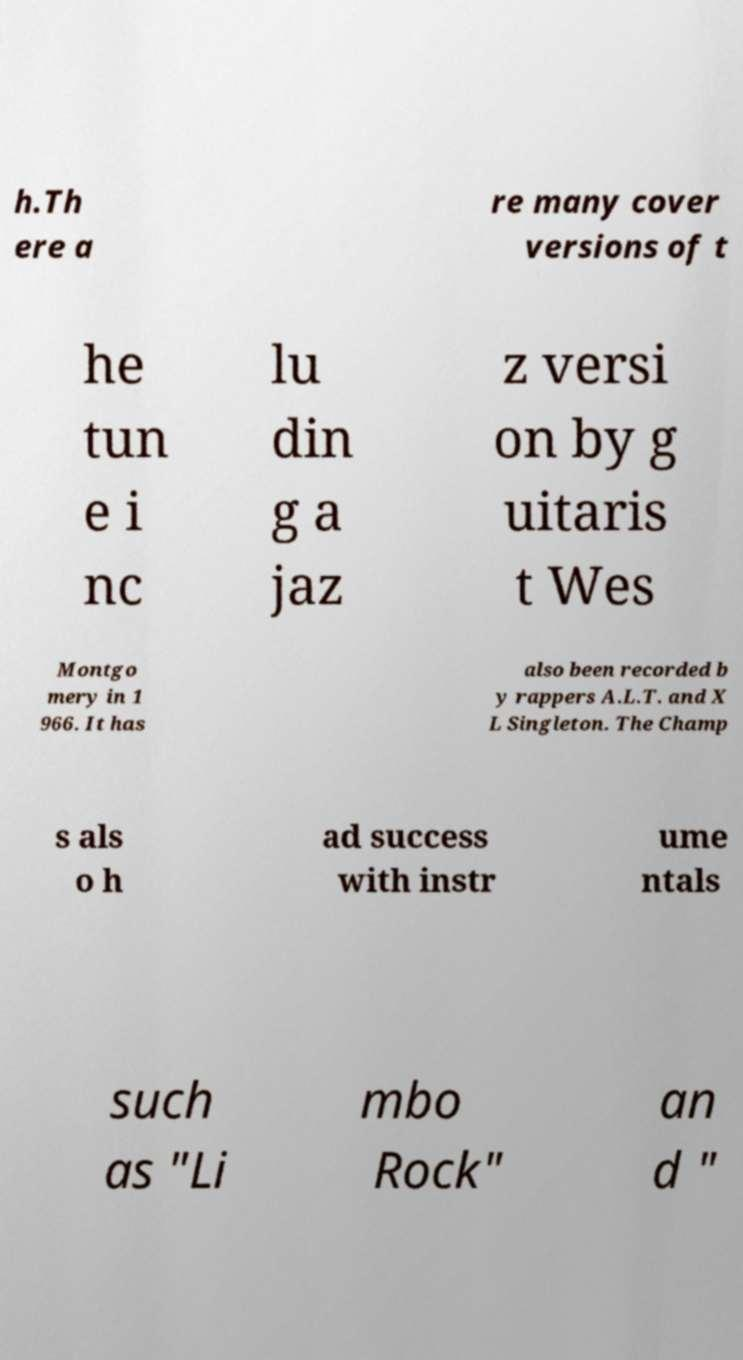There's text embedded in this image that I need extracted. Can you transcribe it verbatim? h.Th ere a re many cover versions of t he tun e i nc lu din g a jaz z versi on by g uitaris t Wes Montgo mery in 1 966. It has also been recorded b y rappers A.L.T. and X L Singleton. The Champ s als o h ad success with instr ume ntals such as "Li mbo Rock" an d " 